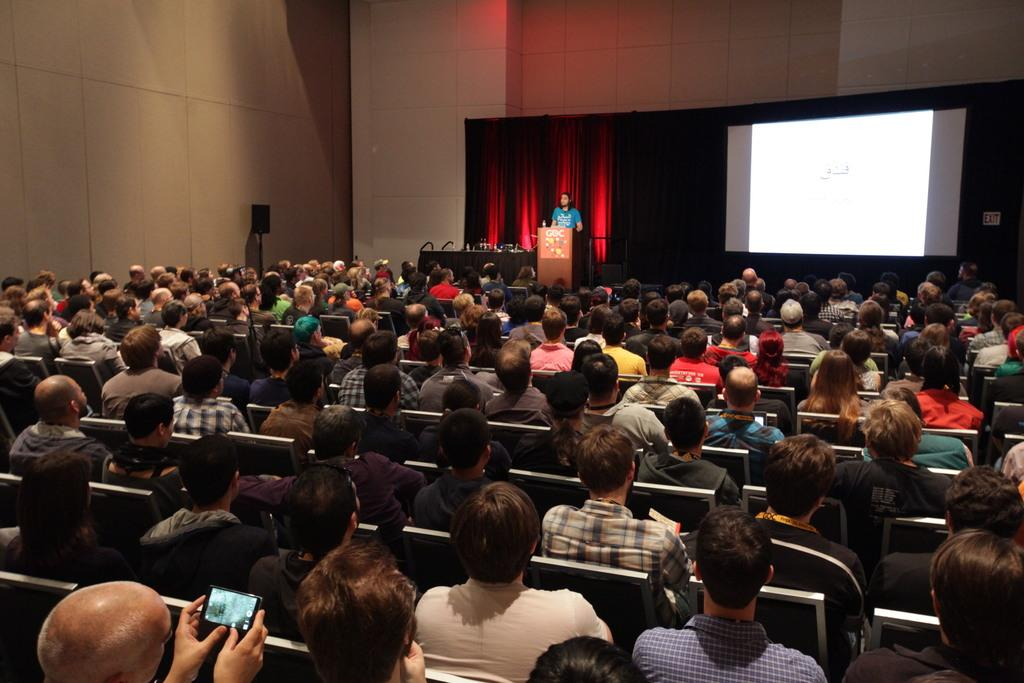How many people are in the image? There is a group of people in the image. What are the people doing in the image? The people are sitting on chairs. Who is standing in the image? There is a man standing at a podium. What objects can be seen in the image besides the people? There is a mobile, a screen, and curtains visible in the image. What is in the background of the image? There is a wall visible in the background of the image? What type of beam is holding up the ceiling in the image? There is no beam visible in the image; it does not show the ceiling or any structural elements. 